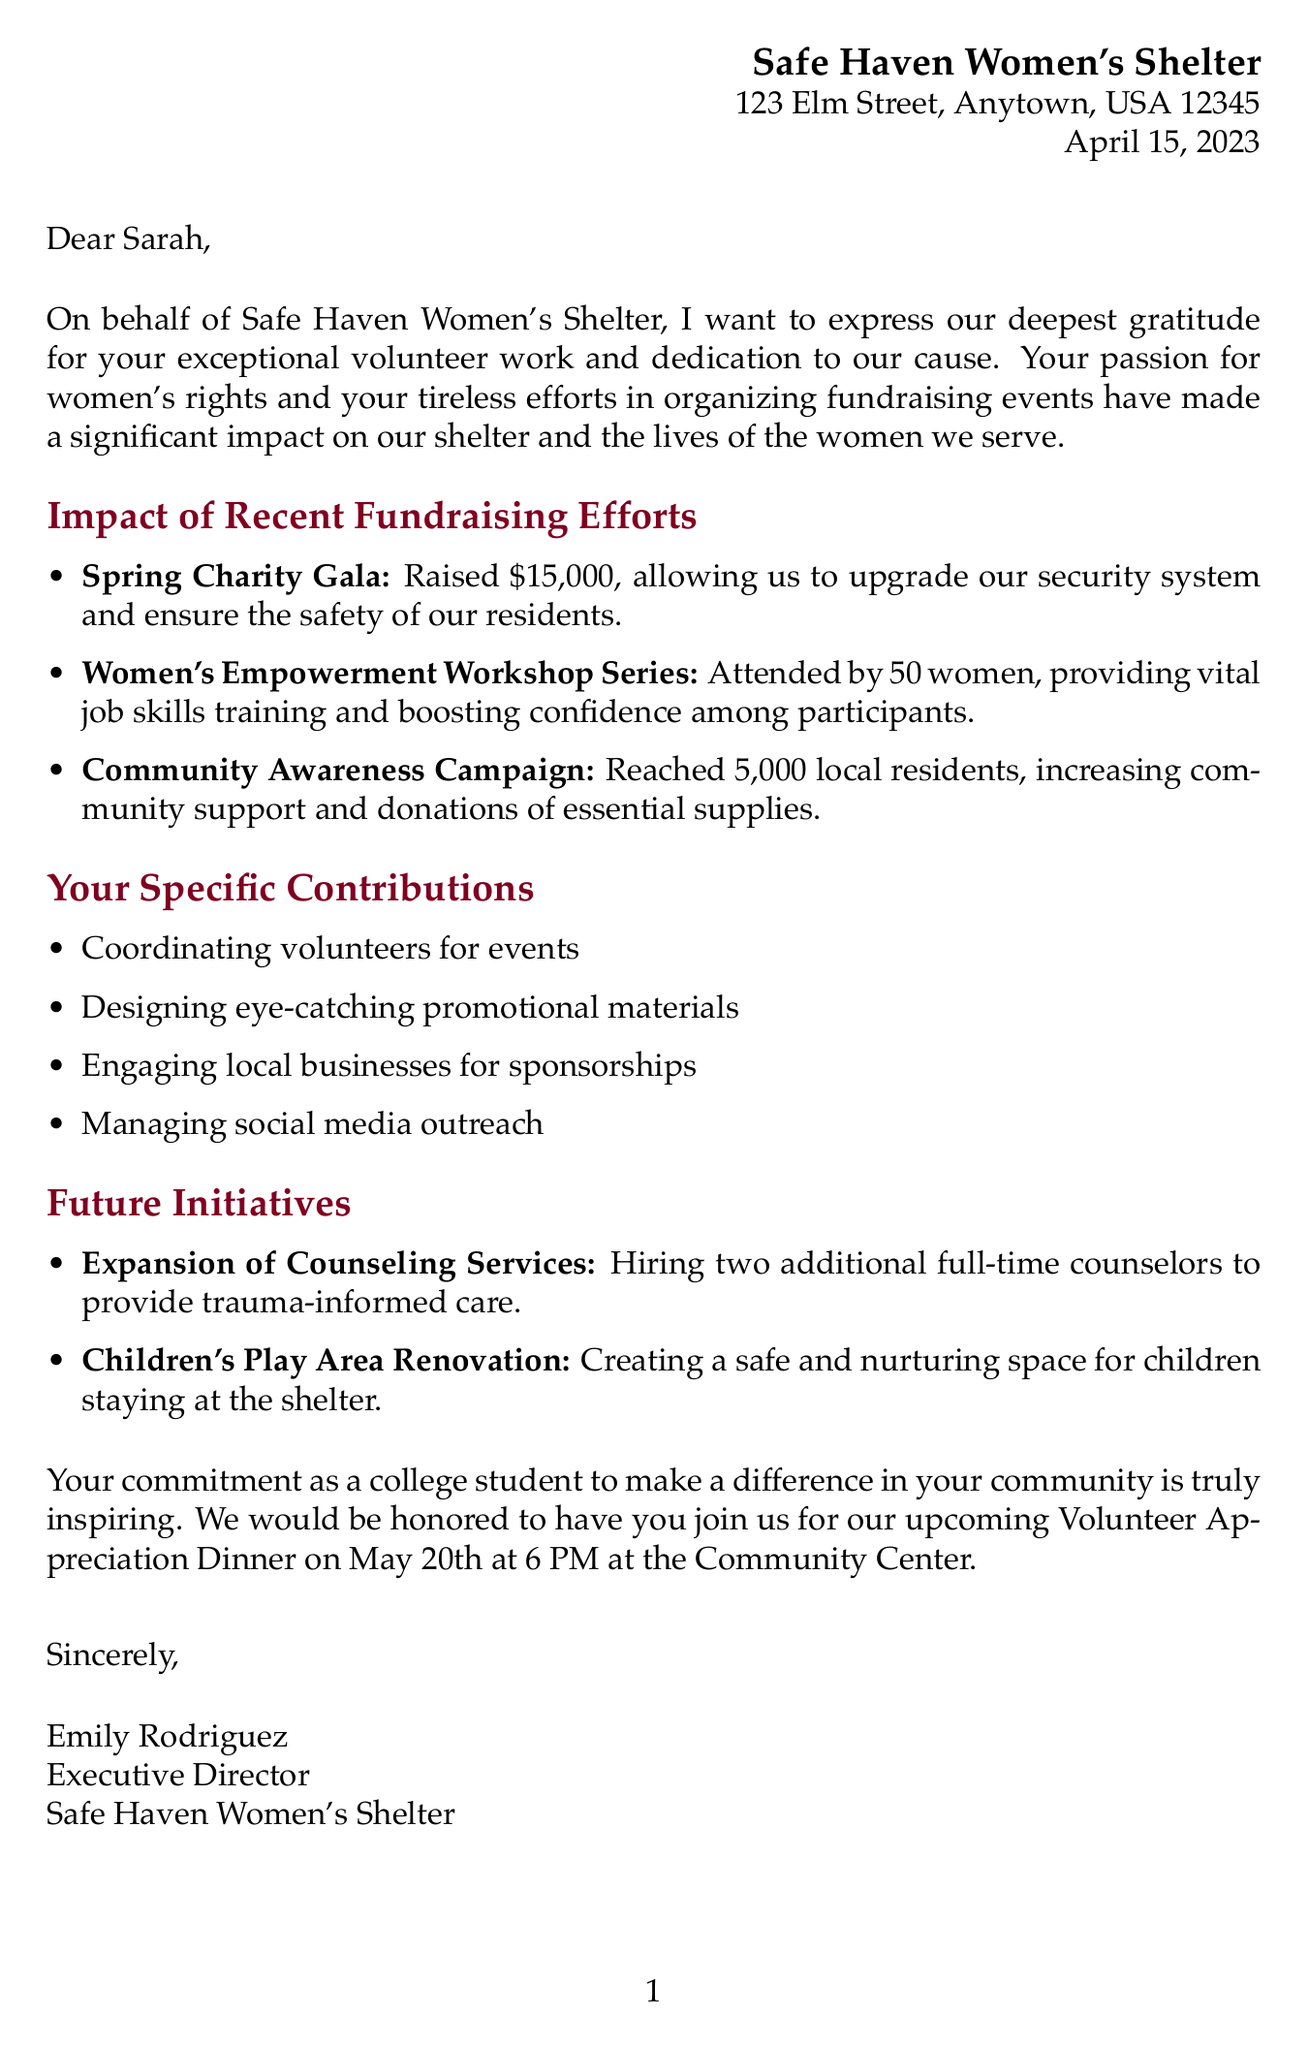What is the organization name? The organization name is listed at the beginning of the letter.
Answer: Safe Haven Women's Shelter What is the date of the letter? The letter specifies the date in the header section.
Answer: April 15, 2023 How much money was raised during the Spring Charity Gala? The letter provides specific amounts raised for fundraising events, including this one.
Answer: $15,000 How many women attended the Women's Empowerment Workshop Series? The document clearly states the number of attendees for this event.
Answer: 50 women What new service is planned to be expanded? The letter mentions future initiatives concerning various services.
Answer: Counseling Services Who signed the letter? The signature section of the letter identifies the person who signed it.
Answer: Emily Rodriguez What event is scheduled for May 20th? The closing remarks mention an event along with its date.
Answer: Volunteer Appreciation Dinner What was one of the impacts of the Community Awareness Campaign? The document describes the impact of this specific event within its details.
Answer: Increased community support What specific contribution involved social media? The list of specific contributions includes social media-related tasks.
Answer: Managing social media outreach 